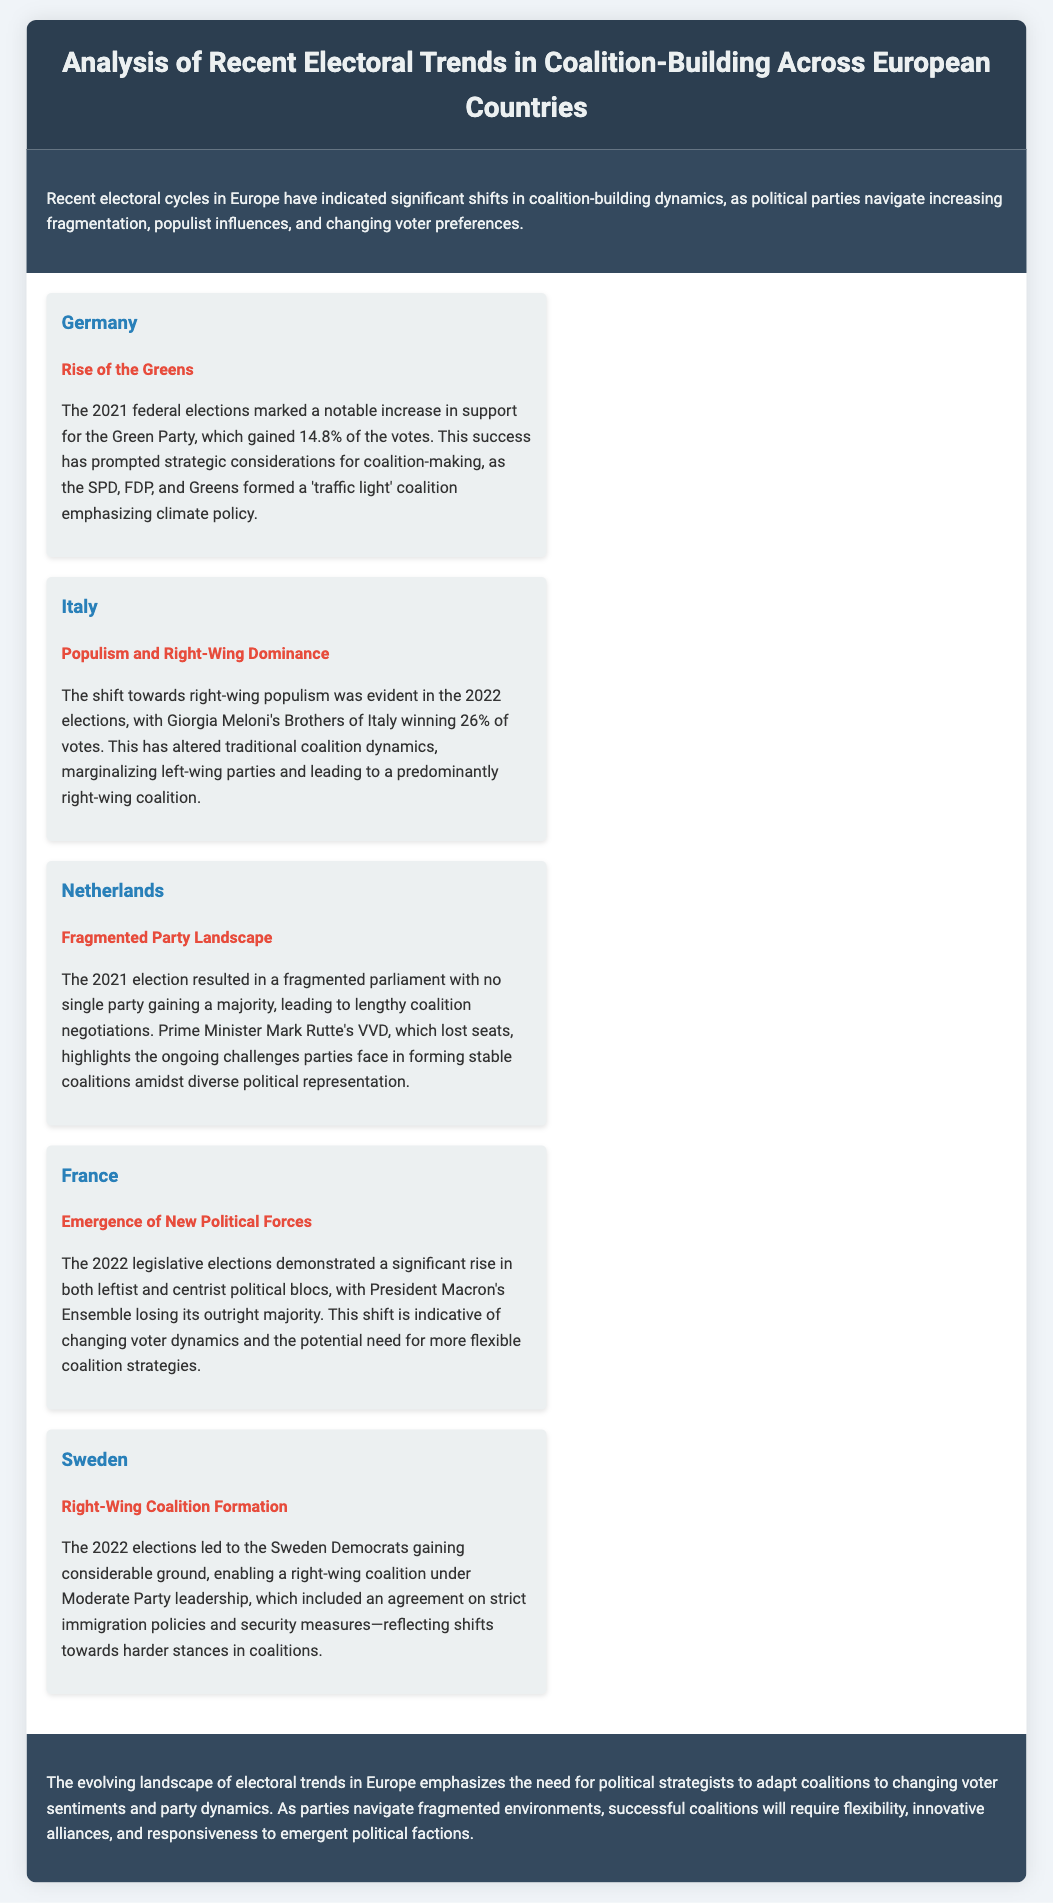What was the percentage of votes gained by the Green Party in Germany? The document states that the Green Party gained 14.8% of the votes in the 2021 federal elections.
Answer: 14.8% Who won 26% of the votes in the 2022 Italian elections? According to the document, Giorgia Meloni's Brothers of Italy won 26% of the votes in the 2022 elections.
Answer: Brothers of Italy What type of coalition was formed in Germany? The document mentions a 'traffic light' coalition was formed, emphasizing climate policy.
Answer: 'Traffic light' coalition Which country experienced a fragmented parliament in the 2021 election? The Netherlands is noted for a fragmented parliament following the 2021 election, leading to lengthy coalition negotiations.
Answer: Netherlands What was the trend in Sweden's 2022 elections? The document highlights the formation of a right-wing coalition under Moderate Party leadership in Sweden.
Answer: Right-Wing Coalition Formation What was the significant outcome of the 2022 French legislative elections? The 2022 elections in France resulted in President Macron's Ensemble losing its outright majority.
Answer: Lost its outright majority Which major political shift is indicated for the Netherlands? The document indicates ongoing challenges for parties in forming stable coalitions amid diverse political representation.
Answer: Fragmented Party Landscape What is emphasized as necessary for successful coalitions according to the conclusion? The conclusion highlights the need for flexibility, innovative alliances, and responsiveness to emergent political factions.
Answer: Flexibility, innovative alliances, responsiveness 